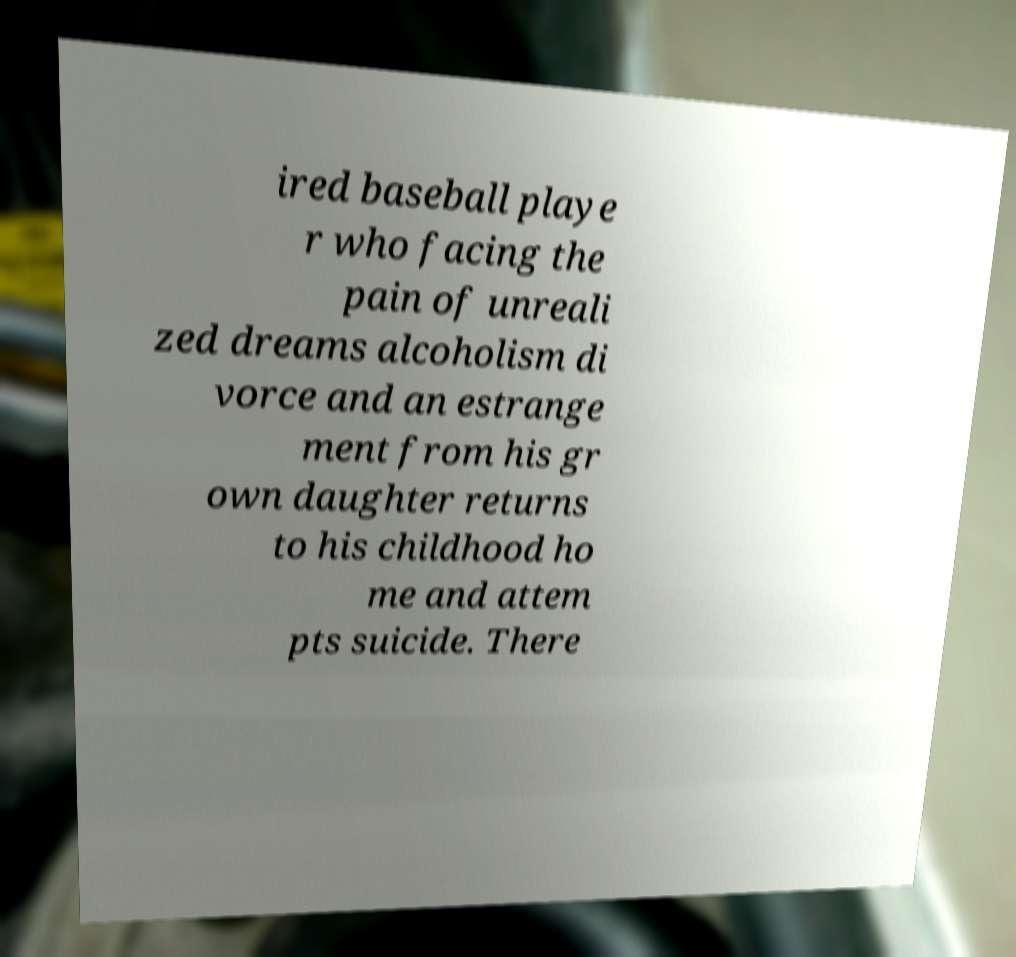Can you read and provide the text displayed in the image?This photo seems to have some interesting text. Can you extract and type it out for me? ired baseball playe r who facing the pain of unreali zed dreams alcoholism di vorce and an estrange ment from his gr own daughter returns to his childhood ho me and attem pts suicide. There 